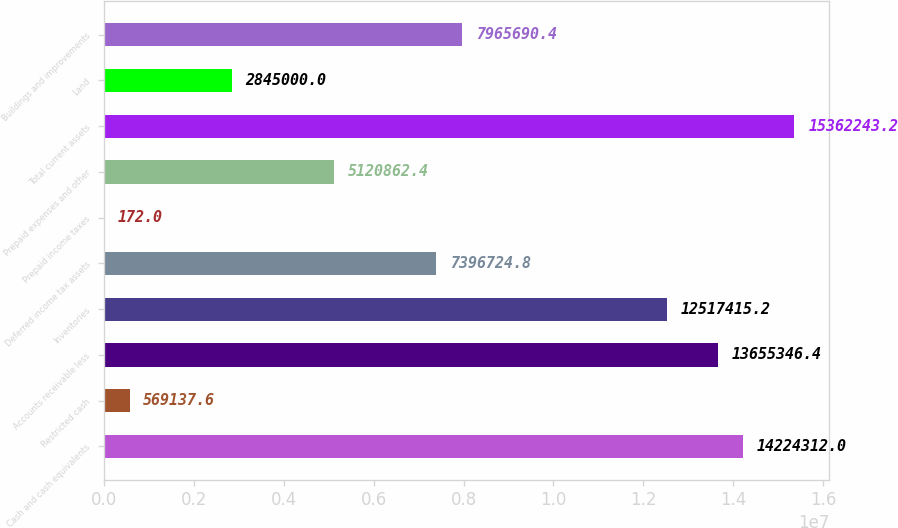Convert chart. <chart><loc_0><loc_0><loc_500><loc_500><bar_chart><fcel>Cash and cash equivalents<fcel>Restricted cash<fcel>Accounts receivable less<fcel>Inventories<fcel>Deferred income tax assets<fcel>Prepaid income taxes<fcel>Prepaid expenses and other<fcel>Total current assets<fcel>Land<fcel>Buildings and improvements<nl><fcel>1.42243e+07<fcel>569138<fcel>1.36553e+07<fcel>1.25174e+07<fcel>7.39672e+06<fcel>172<fcel>5.12086e+06<fcel>1.53622e+07<fcel>2.845e+06<fcel>7.96569e+06<nl></chart> 